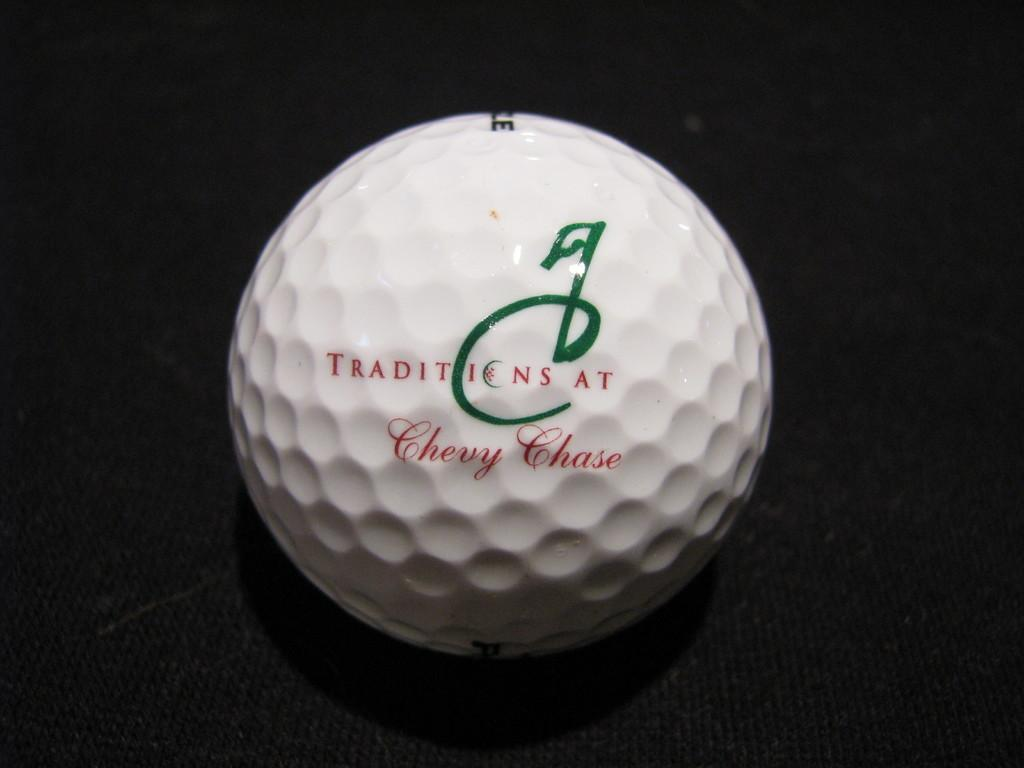What object is the main subject of the image? There is a ball in the image. What color is the ball? The ball is white. Is there any text or writing on the ball? Yes, the ball has a name written on it in red color. What type of building can be seen in the background of the image? There is no building present in the image; it only features a white ball with a name written on it in red color. 